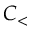Convert formula to latex. <formula><loc_0><loc_0><loc_500><loc_500>C _ { < }</formula> 